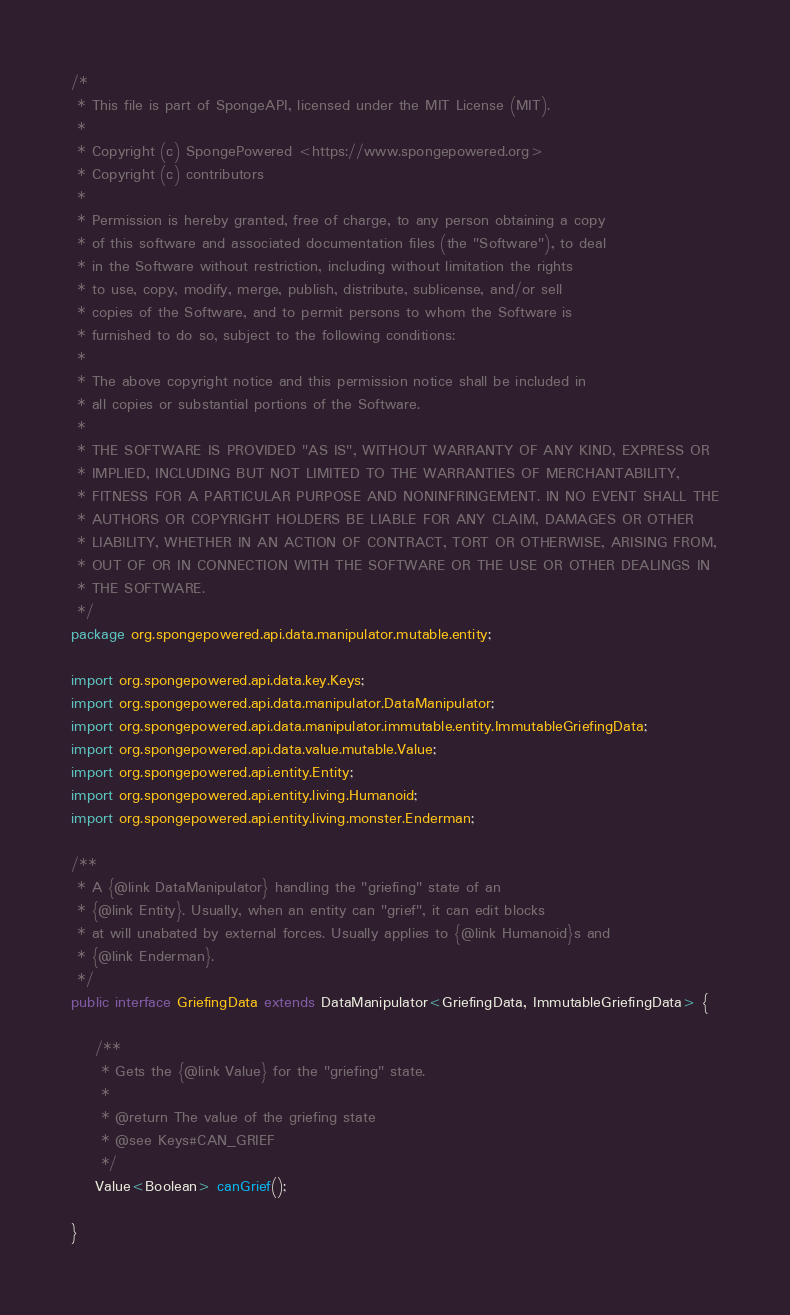Convert code to text. <code><loc_0><loc_0><loc_500><loc_500><_Java_>/*
 * This file is part of SpongeAPI, licensed under the MIT License (MIT).
 *
 * Copyright (c) SpongePowered <https://www.spongepowered.org>
 * Copyright (c) contributors
 *
 * Permission is hereby granted, free of charge, to any person obtaining a copy
 * of this software and associated documentation files (the "Software"), to deal
 * in the Software without restriction, including without limitation the rights
 * to use, copy, modify, merge, publish, distribute, sublicense, and/or sell
 * copies of the Software, and to permit persons to whom the Software is
 * furnished to do so, subject to the following conditions:
 *
 * The above copyright notice and this permission notice shall be included in
 * all copies or substantial portions of the Software.
 *
 * THE SOFTWARE IS PROVIDED "AS IS", WITHOUT WARRANTY OF ANY KIND, EXPRESS OR
 * IMPLIED, INCLUDING BUT NOT LIMITED TO THE WARRANTIES OF MERCHANTABILITY,
 * FITNESS FOR A PARTICULAR PURPOSE AND NONINFRINGEMENT. IN NO EVENT SHALL THE
 * AUTHORS OR COPYRIGHT HOLDERS BE LIABLE FOR ANY CLAIM, DAMAGES OR OTHER
 * LIABILITY, WHETHER IN AN ACTION OF CONTRACT, TORT OR OTHERWISE, ARISING FROM,
 * OUT OF OR IN CONNECTION WITH THE SOFTWARE OR THE USE OR OTHER DEALINGS IN
 * THE SOFTWARE.
 */
package org.spongepowered.api.data.manipulator.mutable.entity;

import org.spongepowered.api.data.key.Keys;
import org.spongepowered.api.data.manipulator.DataManipulator;
import org.spongepowered.api.data.manipulator.immutable.entity.ImmutableGriefingData;
import org.spongepowered.api.data.value.mutable.Value;
import org.spongepowered.api.entity.Entity;
import org.spongepowered.api.entity.living.Humanoid;
import org.spongepowered.api.entity.living.monster.Enderman;

/**
 * A {@link DataManipulator} handling the "griefing" state of an
 * {@link Entity}. Usually, when an entity can "grief", it can edit blocks
 * at will unabated by external forces. Usually applies to {@link Humanoid}s and
 * {@link Enderman}.
 */
public interface GriefingData extends DataManipulator<GriefingData, ImmutableGriefingData> {

    /**
     * Gets the {@link Value} for the "griefing" state.
     *
     * @return The value of the griefing state
     * @see Keys#CAN_GRIEF
     */
    Value<Boolean> canGrief();

}
</code> 